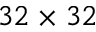Convert formula to latex. <formula><loc_0><loc_0><loc_500><loc_500>3 2 \times 3 2</formula> 